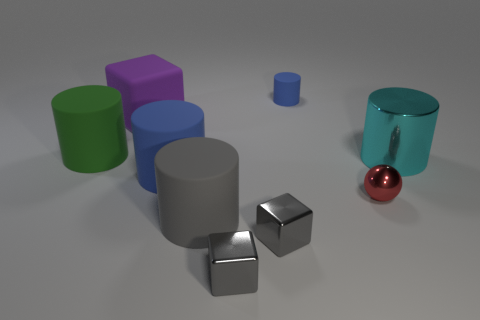Subtract all purple balls. How many gray cubes are left? 2 Subtract 1 blocks. How many blocks are left? 2 Subtract all green cylinders. How many cylinders are left? 4 Subtract all cyan shiny cylinders. How many cylinders are left? 4 Subtract all cyan cylinders. Subtract all brown spheres. How many cylinders are left? 4 Subtract all balls. How many objects are left? 8 Subtract 1 cyan cylinders. How many objects are left? 8 Subtract all tiny blue cubes. Subtract all purple matte objects. How many objects are left? 8 Add 8 red shiny objects. How many red shiny objects are left? 9 Add 2 tiny yellow matte cylinders. How many tiny yellow matte cylinders exist? 2 